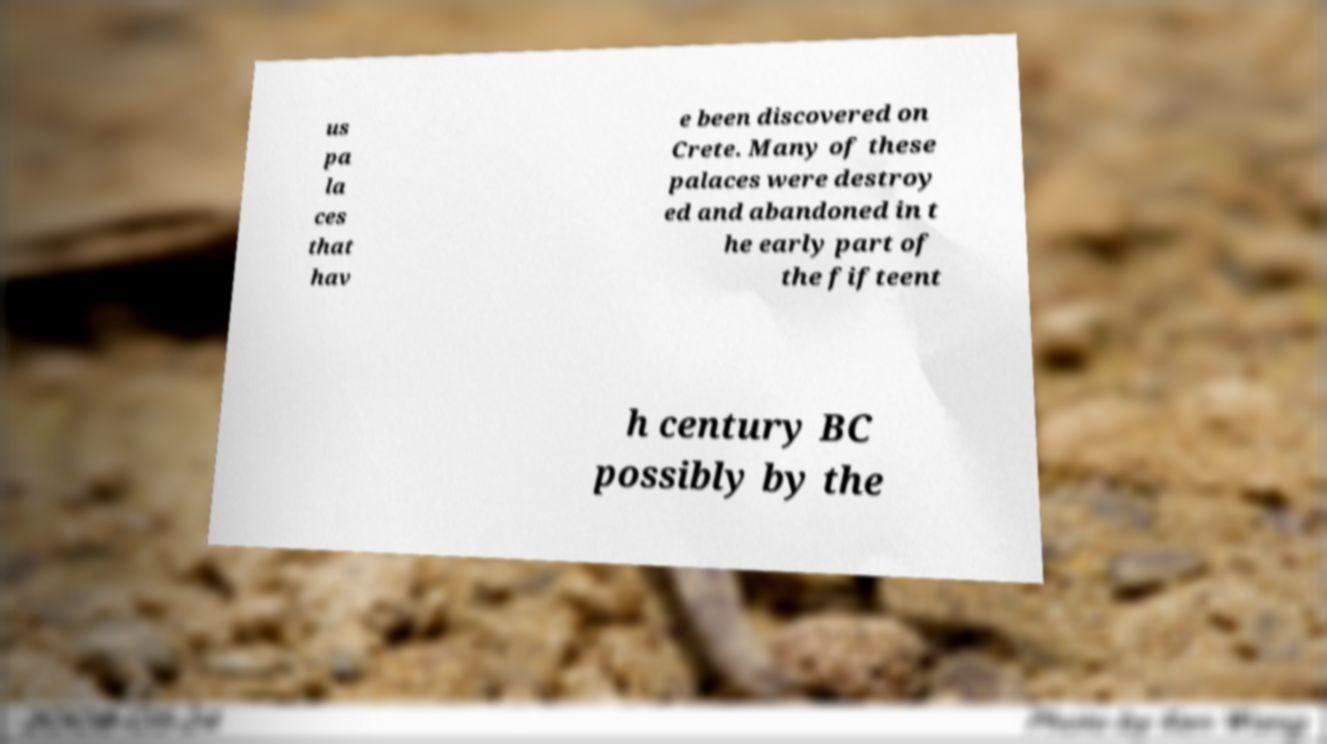For documentation purposes, I need the text within this image transcribed. Could you provide that? us pa la ces that hav e been discovered on Crete. Many of these palaces were destroy ed and abandoned in t he early part of the fifteent h century BC possibly by the 